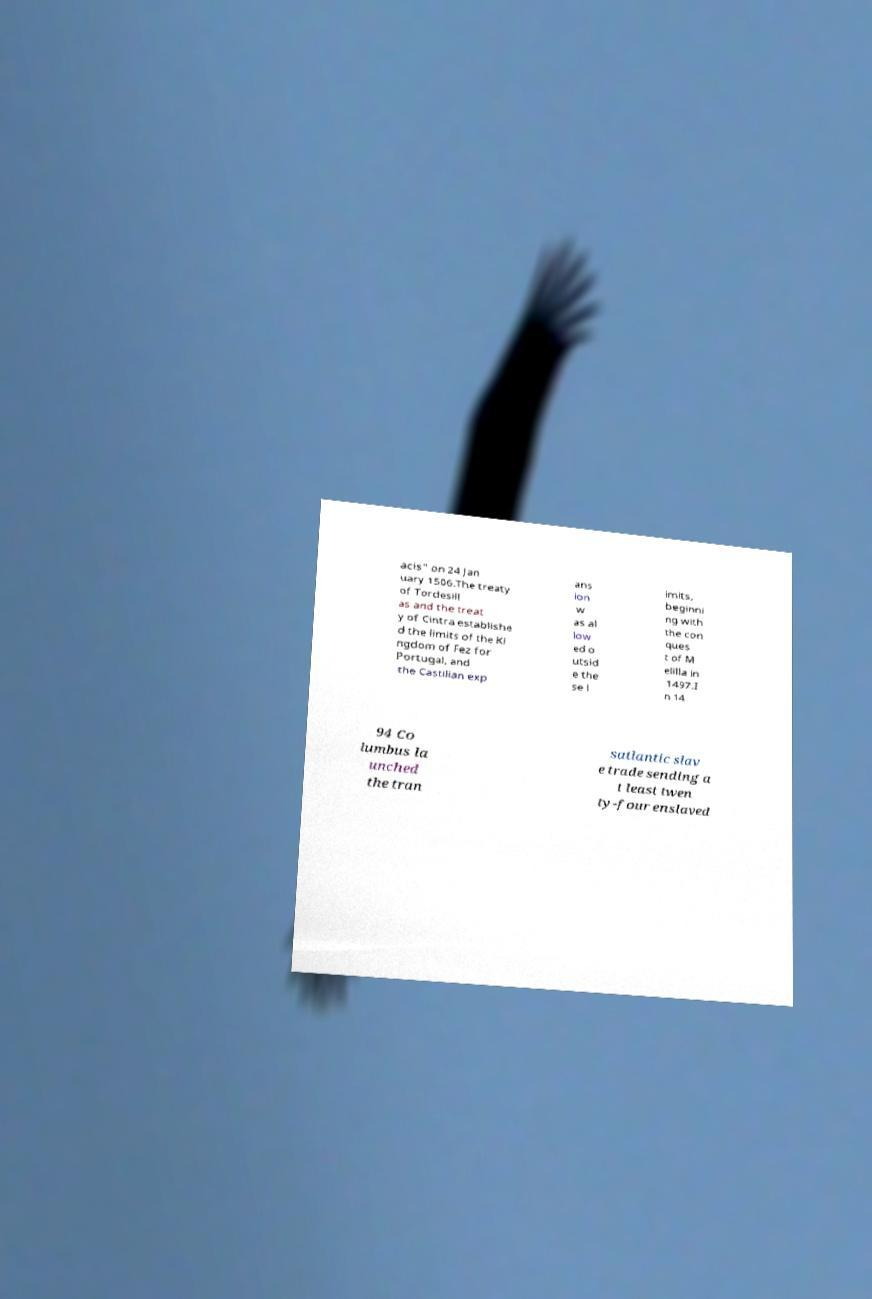Could you extract and type out the text from this image? acis" on 24 Jan uary 1506.The treaty of Tordesill as and the treat y of Cintra establishe d the limits of the Ki ngdom of Fez for Portugal, and the Castilian exp ans ion w as al low ed o utsid e the se l imits, beginni ng with the con ques t of M elilla in 1497.I n 14 94 Co lumbus la unched the tran satlantic slav e trade sending a t least twen ty-four enslaved 